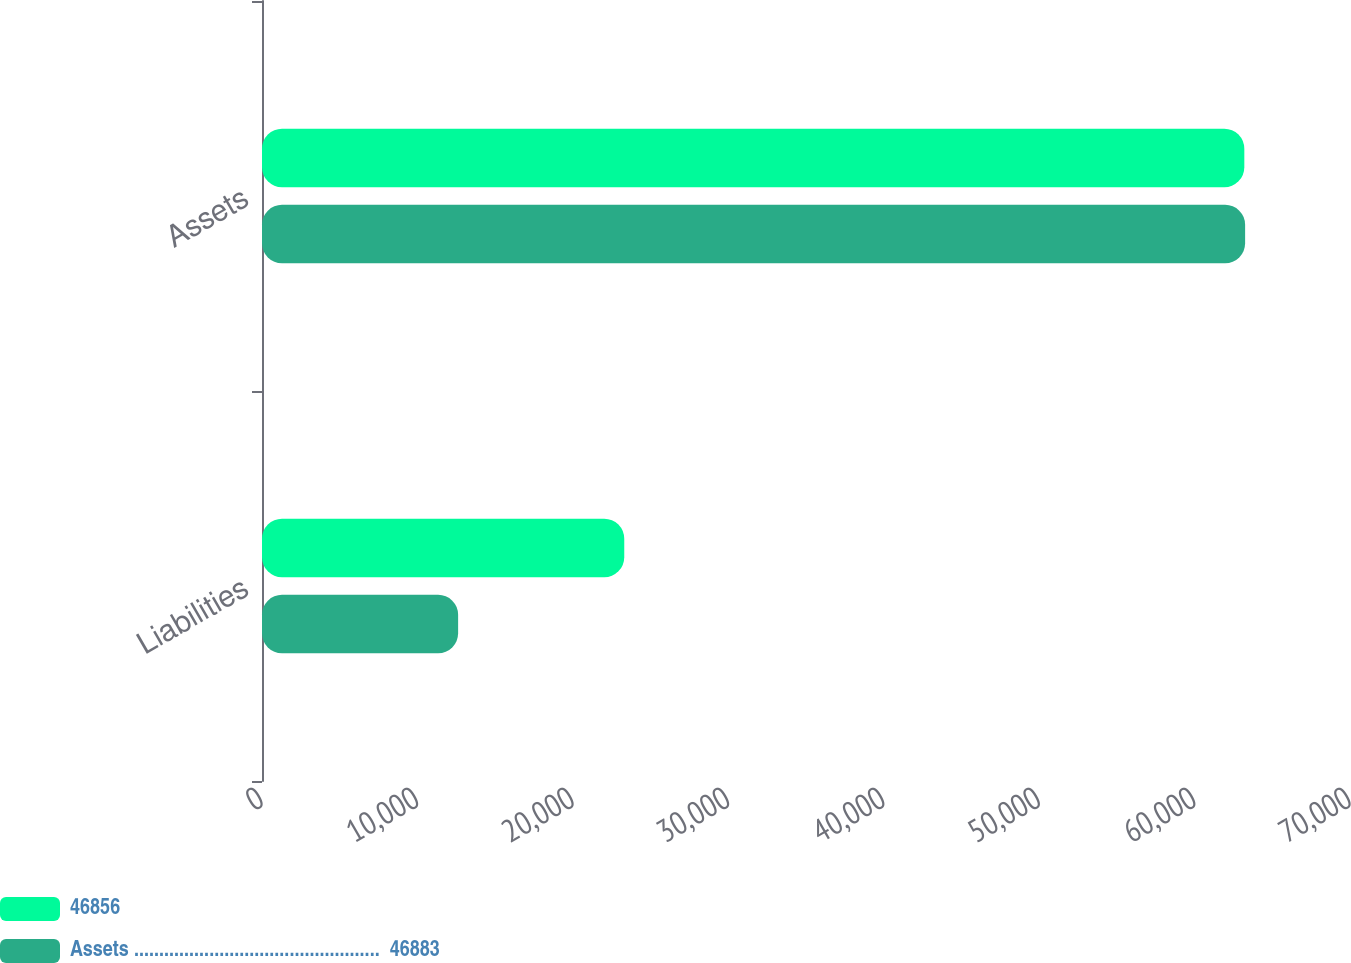Convert chart to OTSL. <chart><loc_0><loc_0><loc_500><loc_500><stacked_bar_chart><ecel><fcel>Liabilities<fcel>Assets<nl><fcel>46856<fcel>23307<fcel>63201<nl><fcel>Assets .................................................  46883<fcel>12618<fcel>63252<nl></chart> 